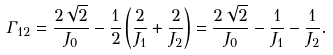Convert formula to latex. <formula><loc_0><loc_0><loc_500><loc_500>\Gamma _ { 1 2 } & = \frac { 2 \sqrt { 2 } } { J _ { 0 } } - \frac { 1 } { 2 } \left ( \frac { 2 } { J _ { 1 } } + \frac { 2 } { J _ { 2 } } \right ) = \frac { 2 \sqrt { 2 } } { J _ { 0 } } - \frac { 1 } { J _ { 1 } } - \frac { 1 } { J _ { 2 } } .</formula> 